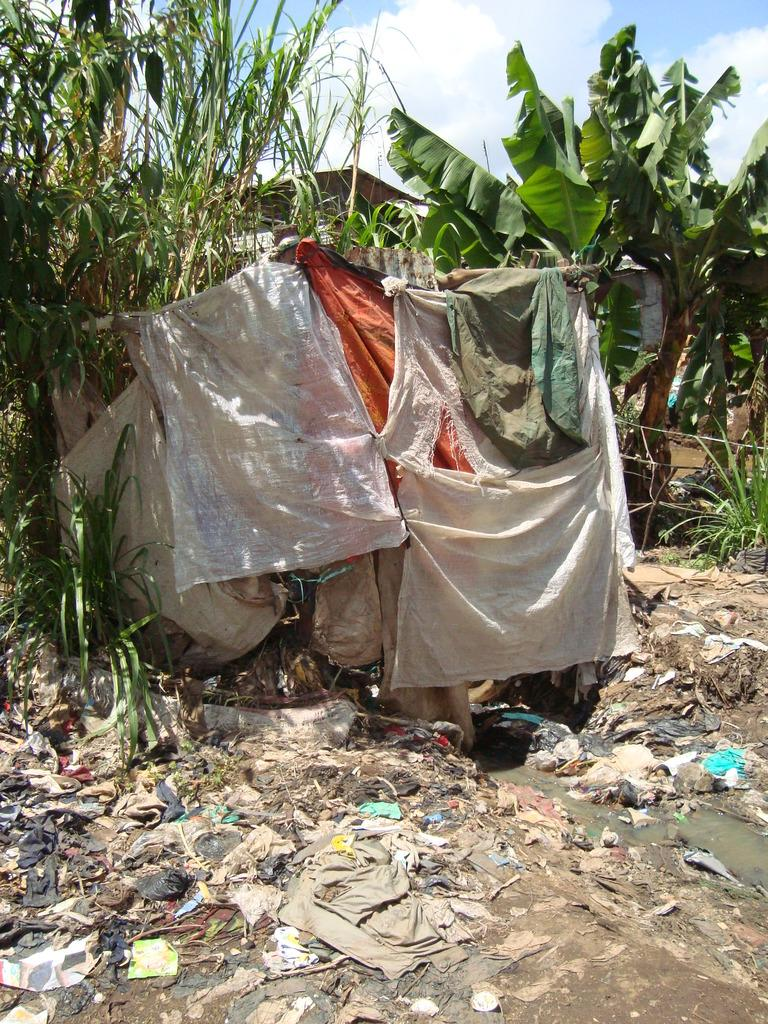What is present in the image that should not be there? There is garbage in the image. What can be seen in the distance in the image? There are trees in the background of the image. What is visible in the sky in the background of the image? There are clouds visible in the sky in the background of the image. Can you see a receipt for the garbage in the image? There is no receipt present in the image. What degree of pollution is visible in the image? The image does not show a degree of pollution; it simply shows garbage. 